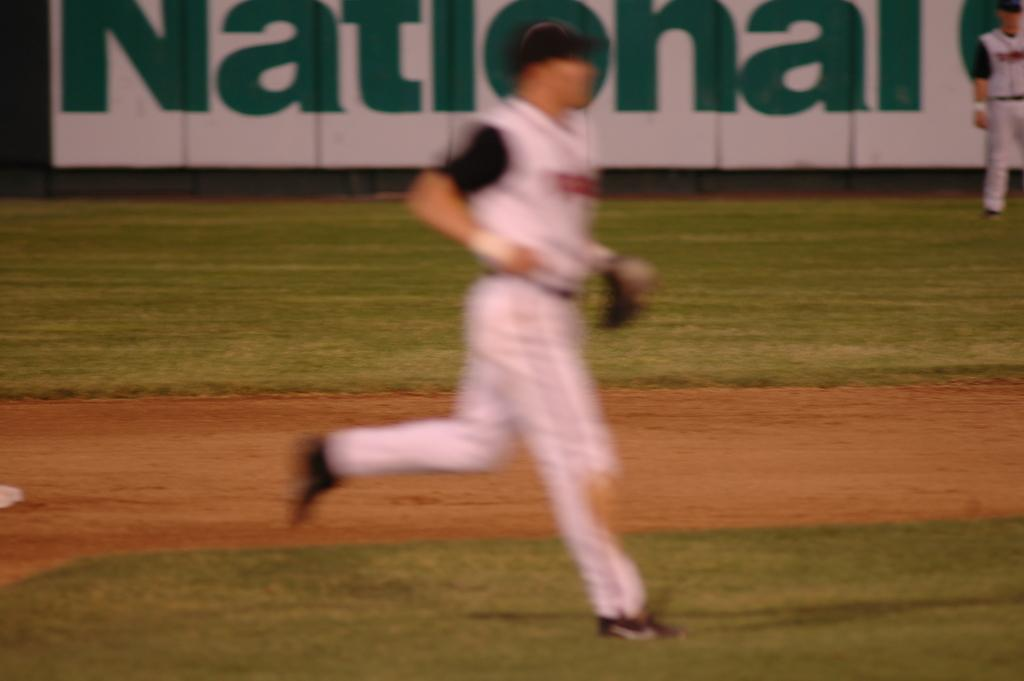<image>
Relay a brief, clear account of the picture shown. The word national can be seen behind a baseball player. 